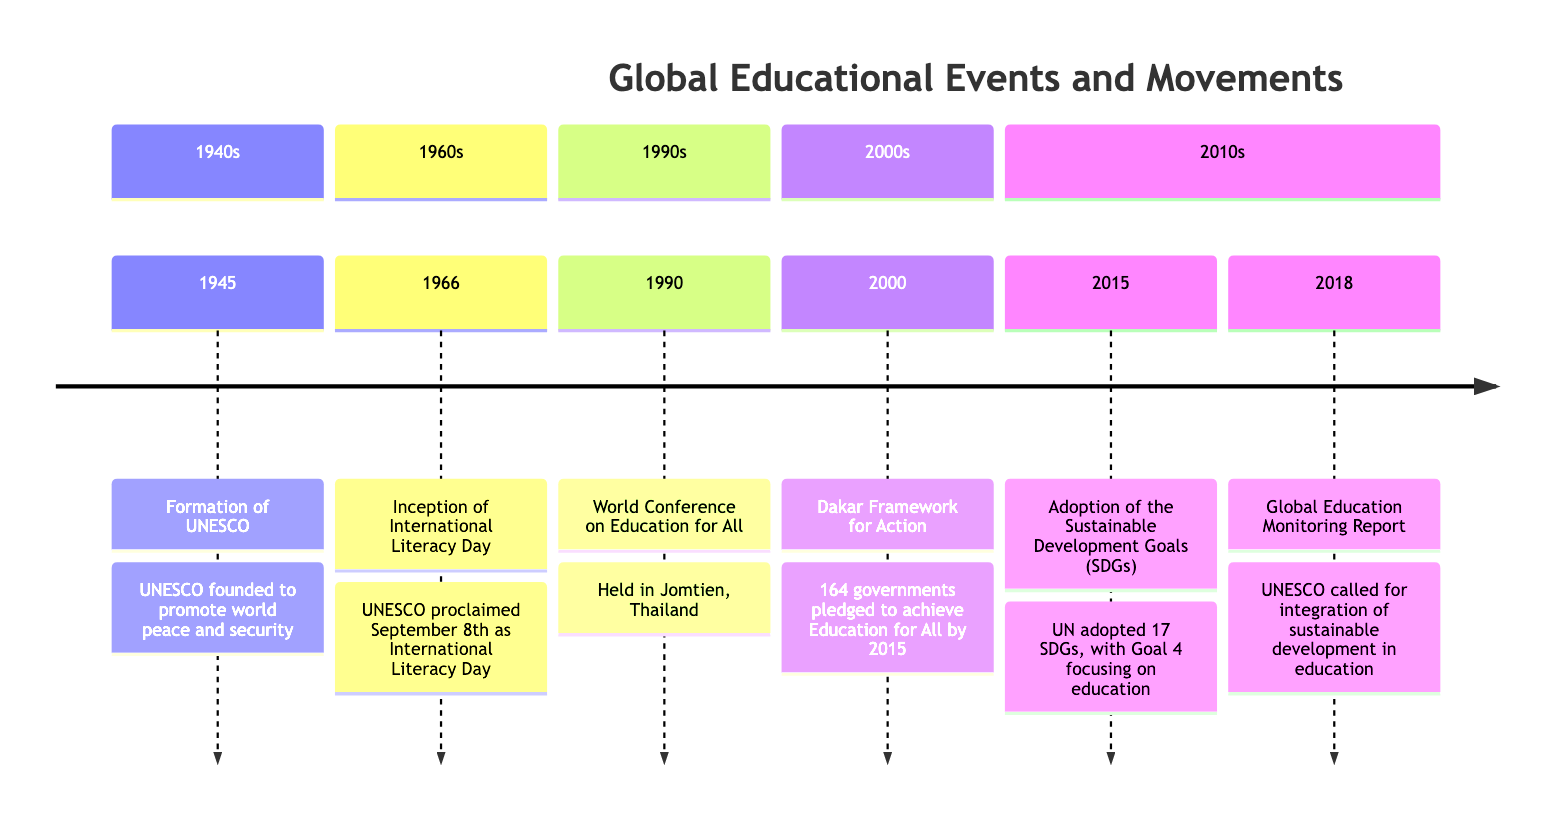What year was the formation of UNESCO? The timeline shows that UNESCO was formed in the year 1945.
Answer: 1945 What event took place in 1990? According to the timeline, the World Conference on Education for All occurred in 1990.
Answer: World Conference on Education for All How many significant educational events are listed in the timeline? There are a total of six events mentioned in the timeline.
Answer: 6 What overarching goal was established in 2000 during the Dakar Framework for Action? The Dakar Framework for Action aimed to achieve Education for All (EFA) by the year 2015.
Answer: Education for All What is the main focus of Sustainable Development Goal 4 adopted in 2015? Sustainable Development Goal 4 focuses on ensuring inclusive and equitable quality education and promoting lifelong learning opportunities for all.
Answer: Inclusive and equitable quality education Which event followed the inception of International Literacy Day? The timeline indicates that the World Conference on Education for All occurred after the inception of International Literacy Day in 1966.
Answer: World Conference on Education for All In which year did UNESCO release the Global Education Monitoring Report? The Global Education Monitoring Report was released in the year 2018.
Answer: 2018 What was the purpose of proclaiming International Literacy Day in 1966? The purpose was to highlight the importance of literacy to individuals, communities, and societies.
Answer: Highlight the importance of literacy Which event has the earliest date on the timeline? The earliest event on the timeline is the formation of UNESCO in 1945.
Answer: Formation of UNESCO 